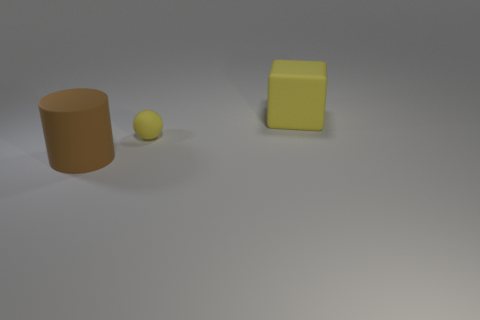Add 2 brown objects. How many objects exist? 5 Subtract all spheres. How many objects are left? 2 Subtract all large blocks. Subtract all brown rubber things. How many objects are left? 1 Add 1 big things. How many big things are left? 3 Add 1 brown things. How many brown things exist? 2 Subtract 1 brown cylinders. How many objects are left? 2 